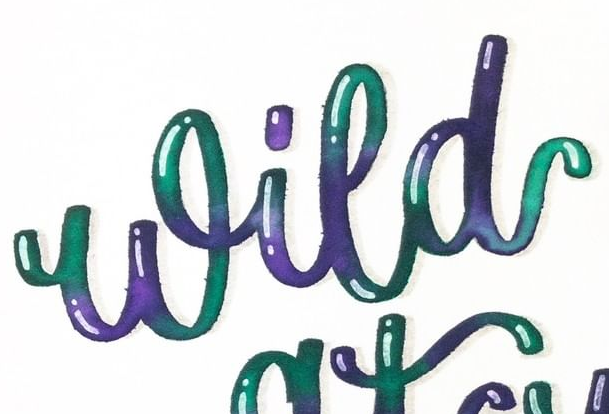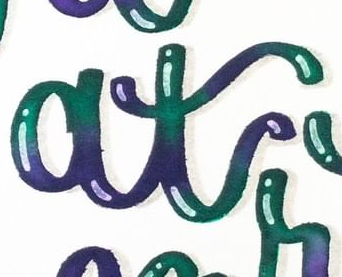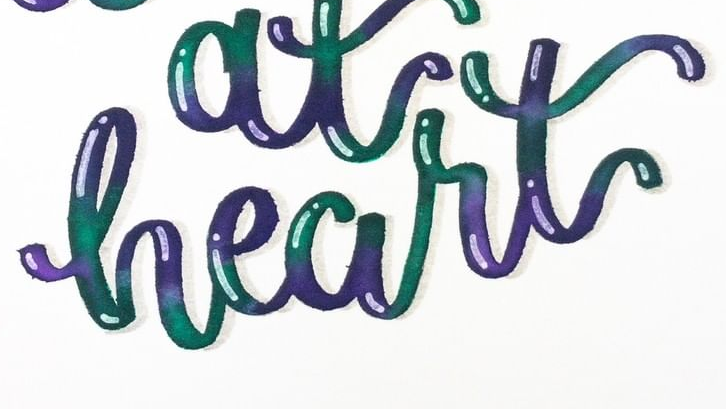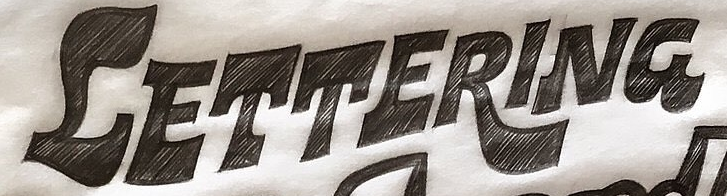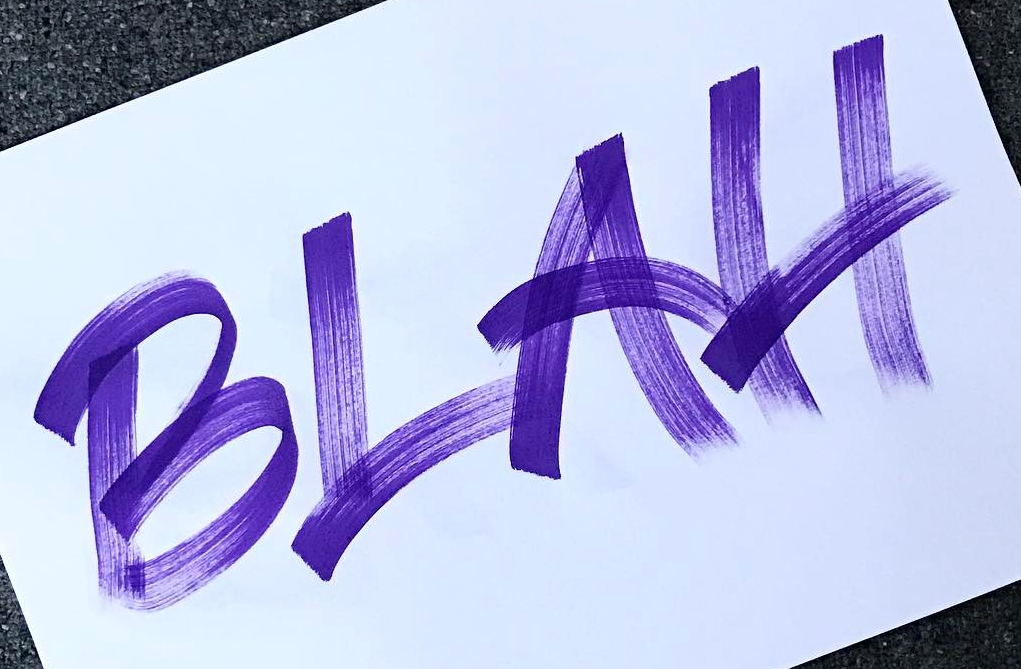What text is displayed in these images sequentially, separated by a semicolon? Wild; at; heart; CETTERING; BLAH 